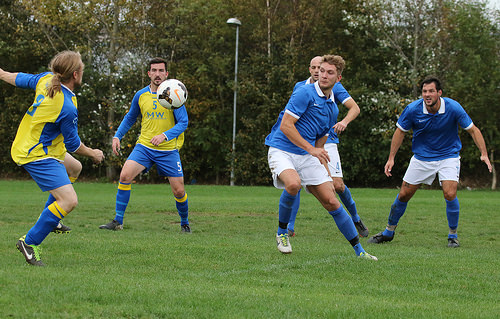<image>
Can you confirm if the light is behind the ball? Yes. From this viewpoint, the light is positioned behind the ball, with the ball partially or fully occluding the light. 